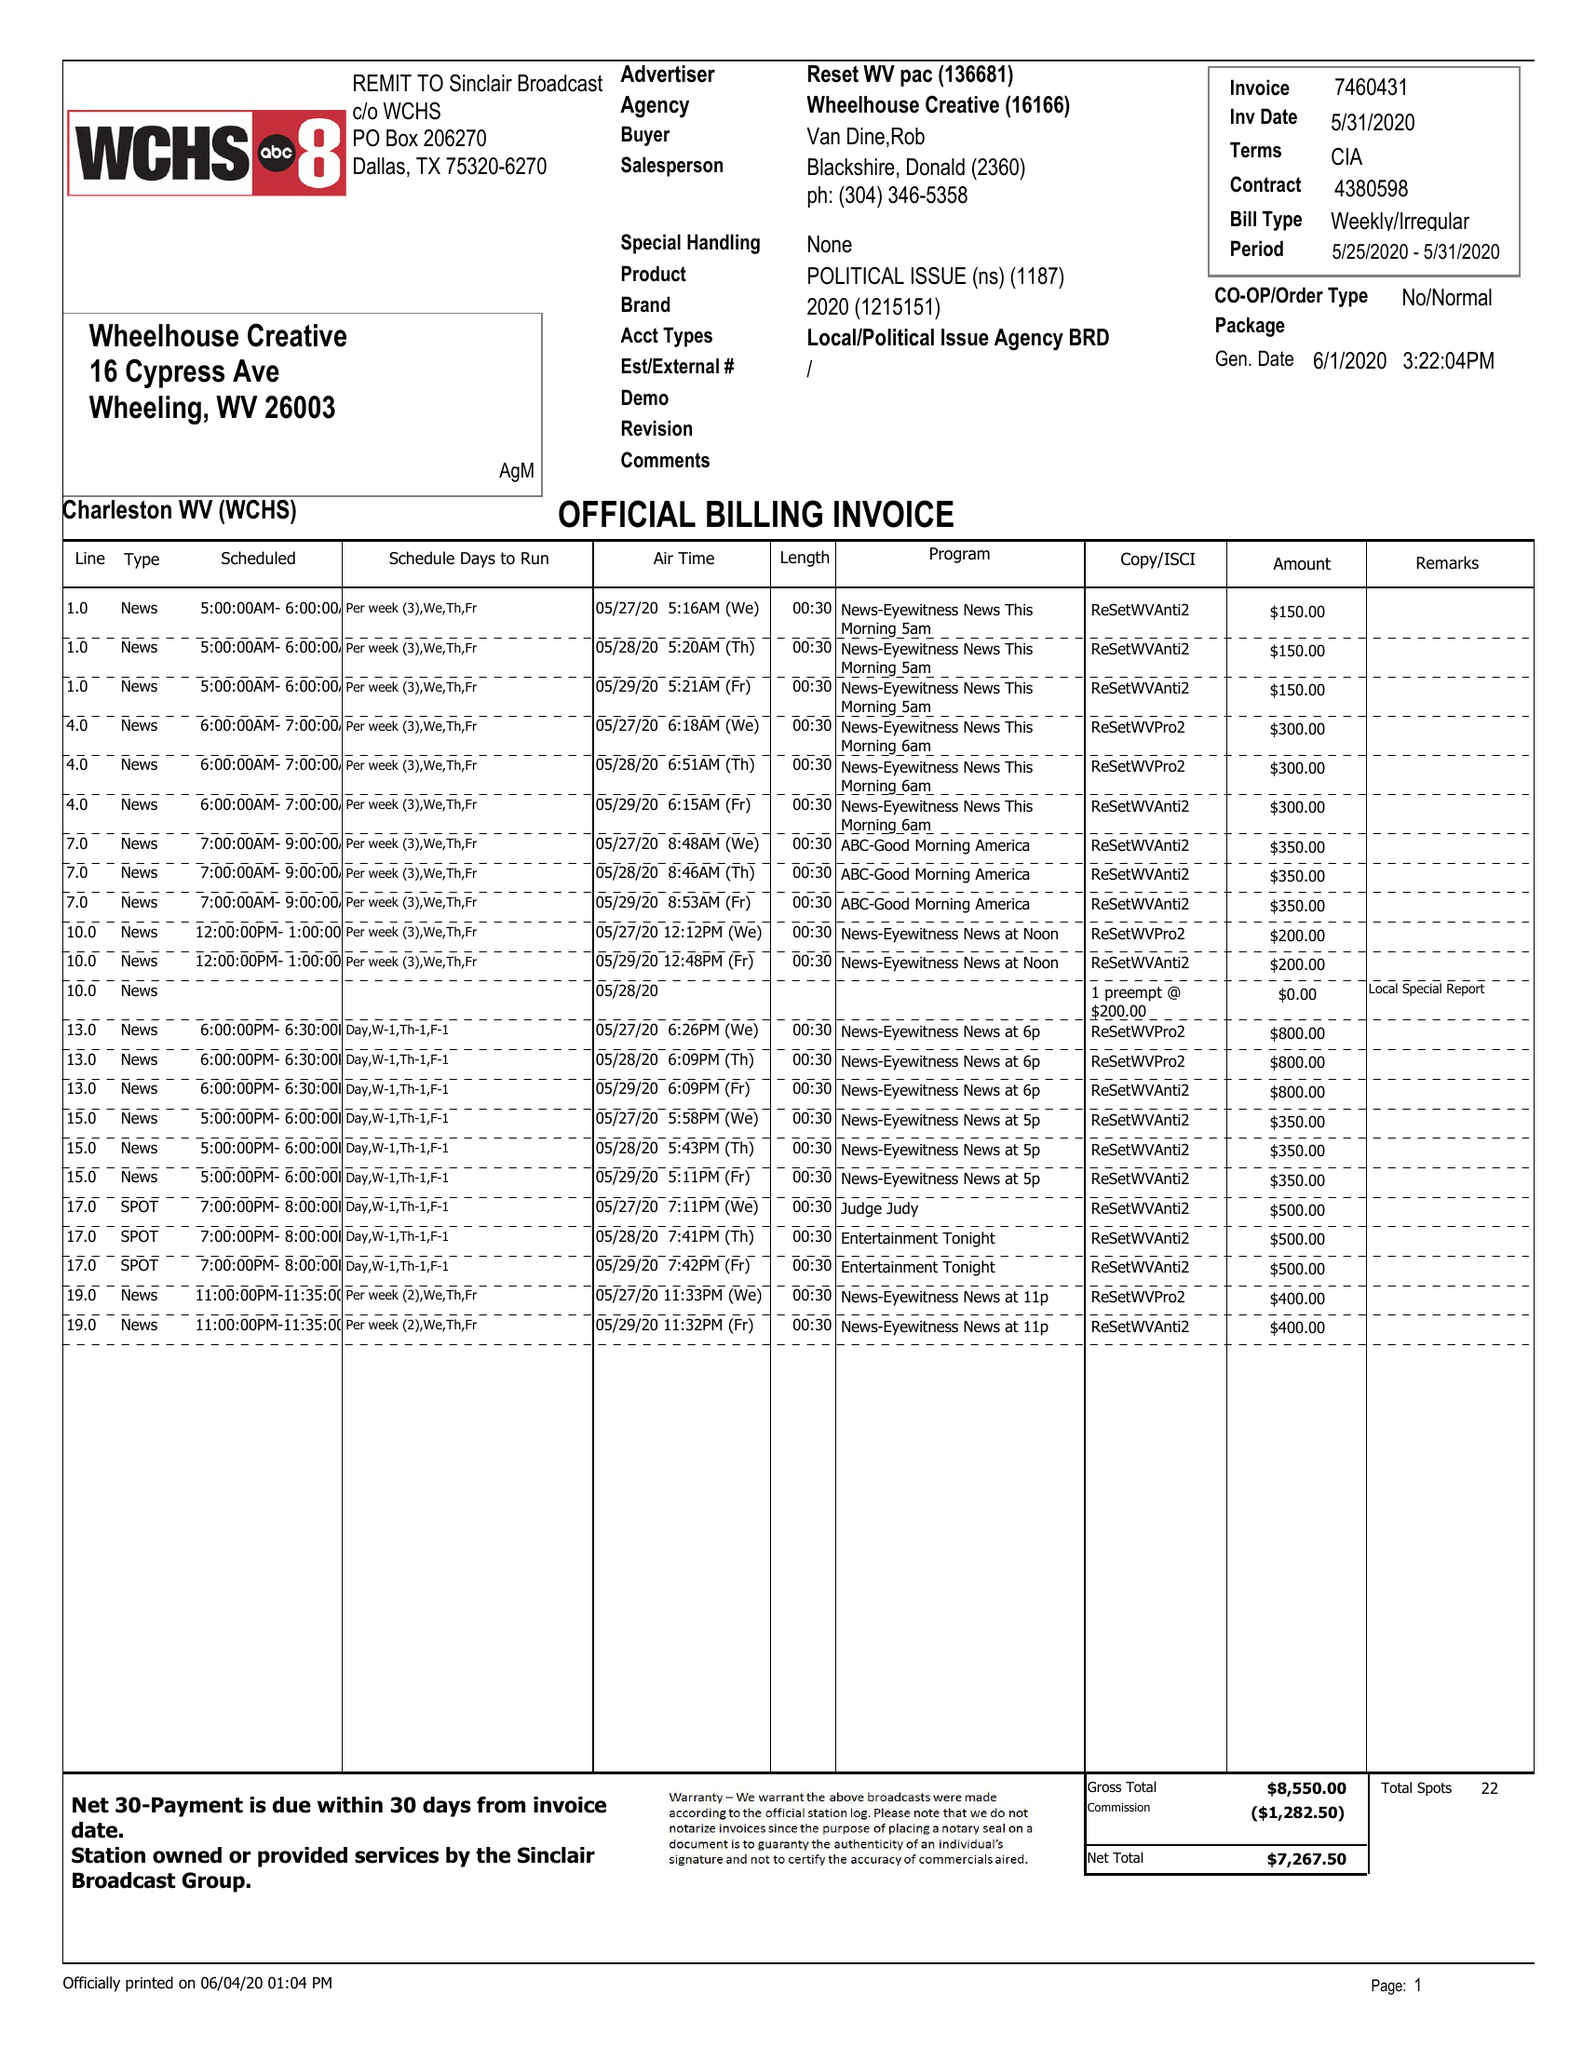What is the value for the flight_from?
Answer the question using a single word or phrase. 05/25/20 